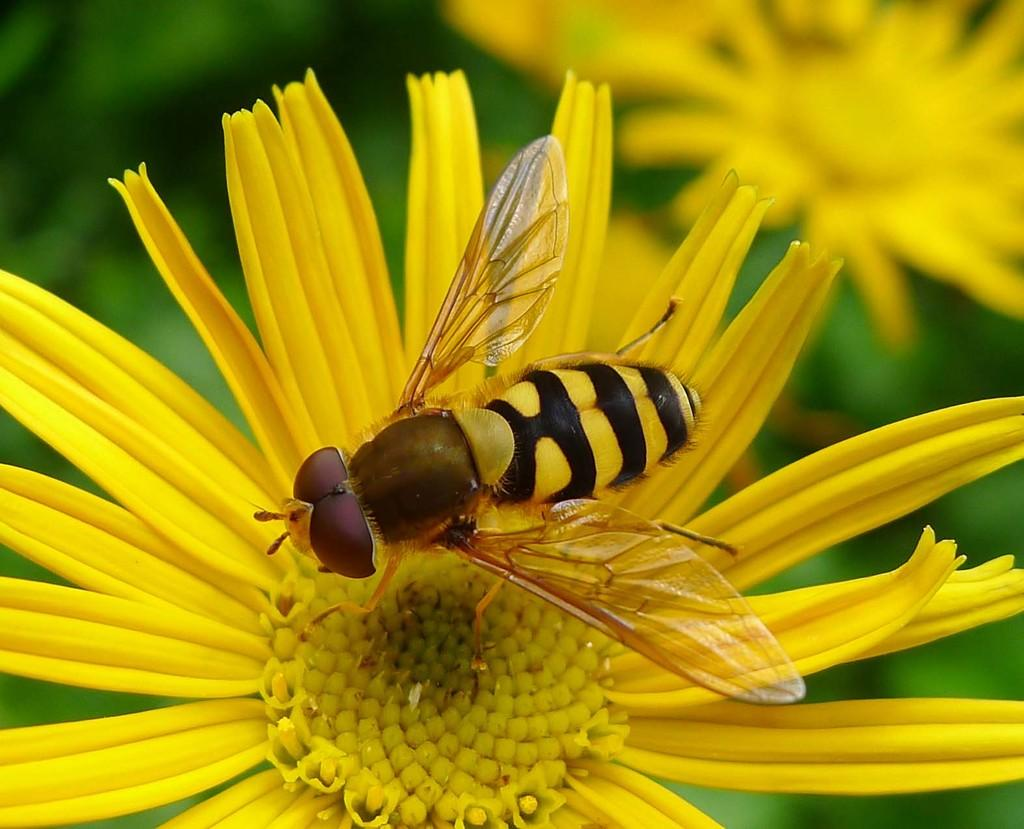What is the main subject in the foreground of the image? There is a bee on a flower in the foreground of the image. What else can be seen in the image besides the bee? There are flowers in the image. Can you describe the background of the image? The background of the image is blurry. What grade does the bee receive for its performance in the image? There is no grading system for bees in the image, as it is a photograph and not a performance evaluation. 